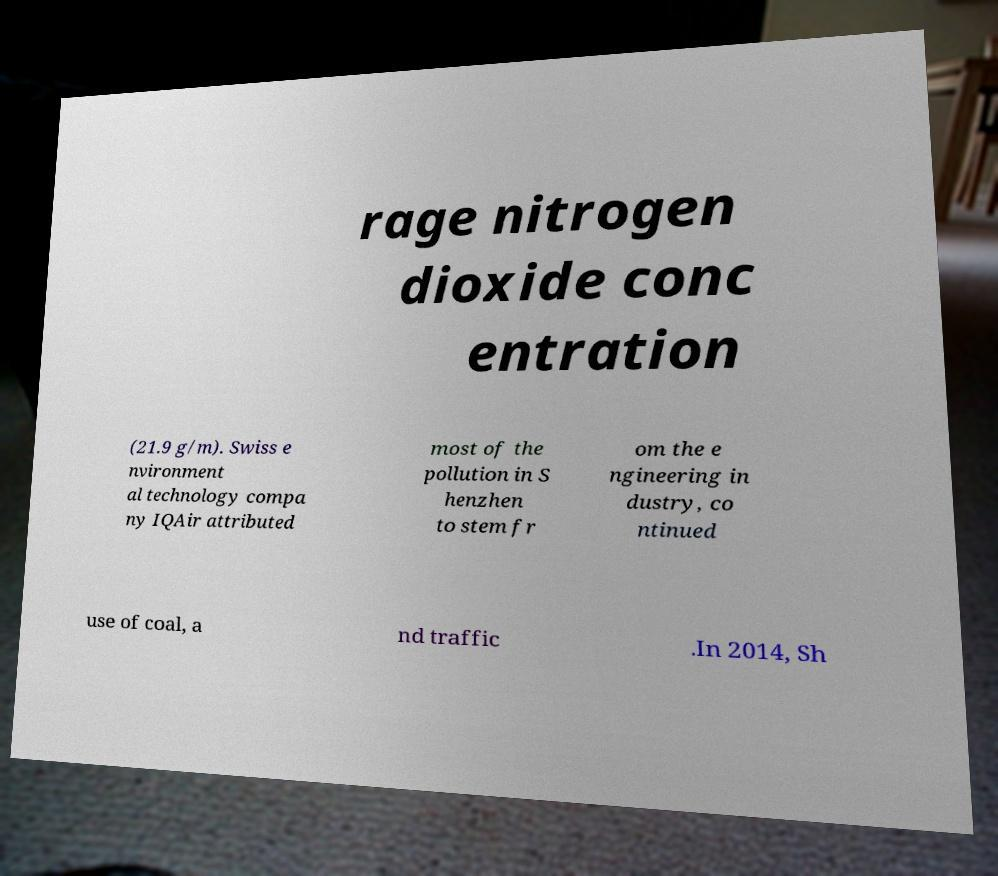Please identify and transcribe the text found in this image. rage nitrogen dioxide conc entration (21.9 g/m). Swiss e nvironment al technology compa ny IQAir attributed most of the pollution in S henzhen to stem fr om the e ngineering in dustry, co ntinued use of coal, a nd traffic .In 2014, Sh 